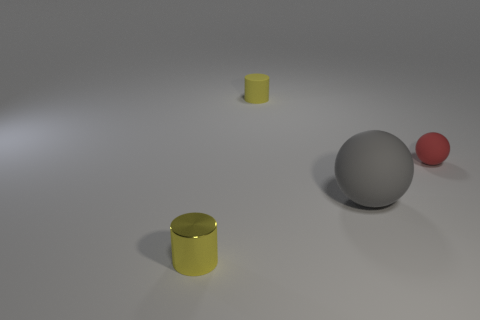What materials could these objects be made of, judging by their appearance? The objects in the image may be made of various materials. The shiny yellow cylinder could be made of polished metal or plastic with a glossy finish, while the matte yellow cylinder could be made of a similar material but with a matte finish. The gray sphere appears to have a metallic finish, suggesting it could be made of steel or aluminum. The red sphere might be plastic given its smooth texture and vibrant color. 